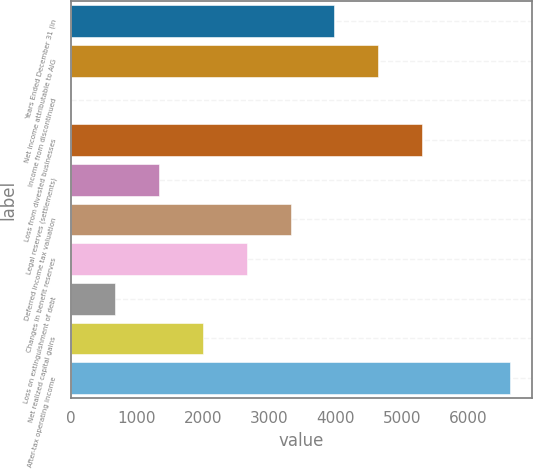<chart> <loc_0><loc_0><loc_500><loc_500><bar_chart><fcel>Years Ended December 31 (in<fcel>Net income attributable to AIG<fcel>Income from discontinued<fcel>Loss from divested businesses<fcel>Legal reserves (settlements)<fcel>Deferred income tax valuation<fcel>Changes in benefit reserves<fcel>Loss on extinguishment of debt<fcel>Net realized capital gains<fcel>After-tax operating income<nl><fcel>3981.4<fcel>4644.8<fcel>1<fcel>5308.2<fcel>1327.8<fcel>3318<fcel>2654.6<fcel>664.4<fcel>1991.2<fcel>6635<nl></chart> 